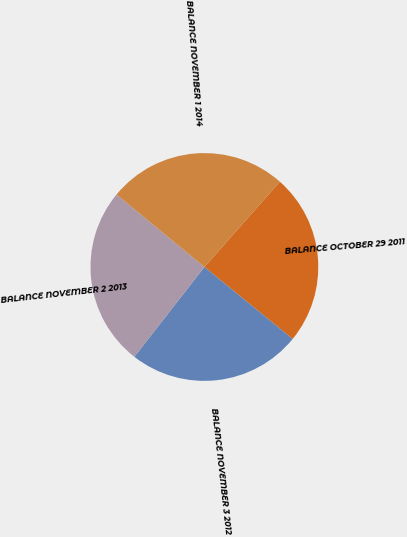Convert chart to OTSL. <chart><loc_0><loc_0><loc_500><loc_500><pie_chart><fcel>BALANCE OCTOBER 29 2011<fcel>BALANCE NOVEMBER 3 2012<fcel>BALANCE NOVEMBER 2 2013<fcel>BALANCE NOVEMBER 1 2014<nl><fcel>24.37%<fcel>24.65%<fcel>25.44%<fcel>25.55%<nl></chart> 